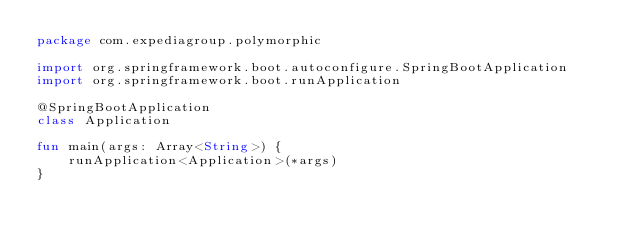<code> <loc_0><loc_0><loc_500><loc_500><_Kotlin_>package com.expediagroup.polymorphic

import org.springframework.boot.autoconfigure.SpringBootApplication
import org.springframework.boot.runApplication

@SpringBootApplication
class Application

fun main(args: Array<String>) {
    runApplication<Application>(*args)
}
</code> 